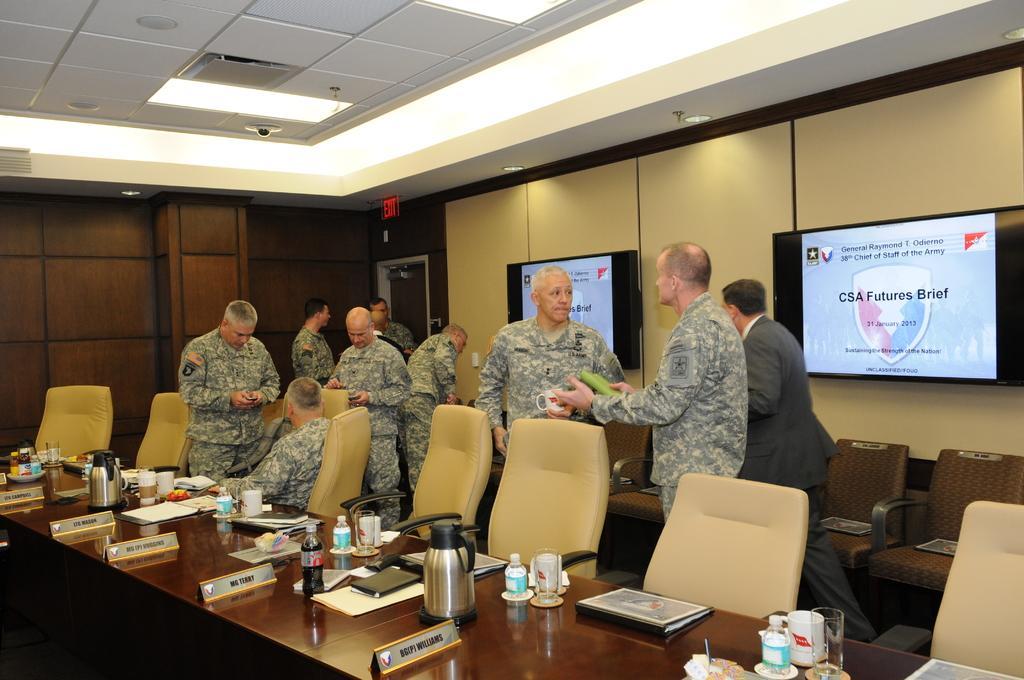Please provide a concise description of this image. This is the picture of a room. In this picture there are group of people standing and there is a person sitting on the chair. There are bottles, glasses, cups, papers, tissues and flasks and boards on the table and there are chairs. At the back there are television and there is text on the screens and there is a door. At the top there are lights. 